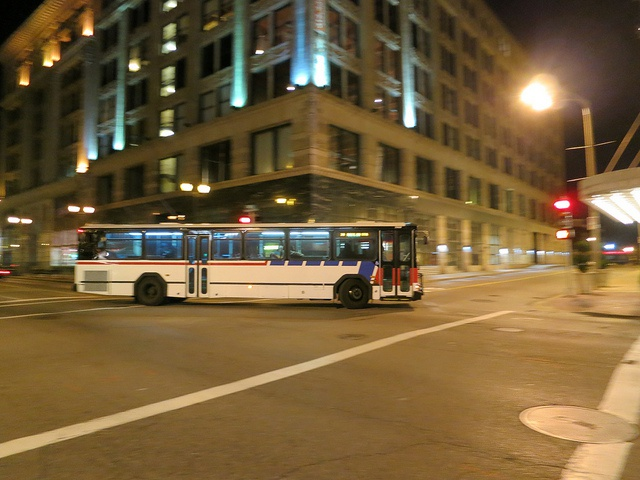Describe the objects in this image and their specific colors. I can see bus in black, tan, and gray tones, traffic light in black, white, red, salmon, and brown tones, and traffic light in black, white, brown, and salmon tones in this image. 